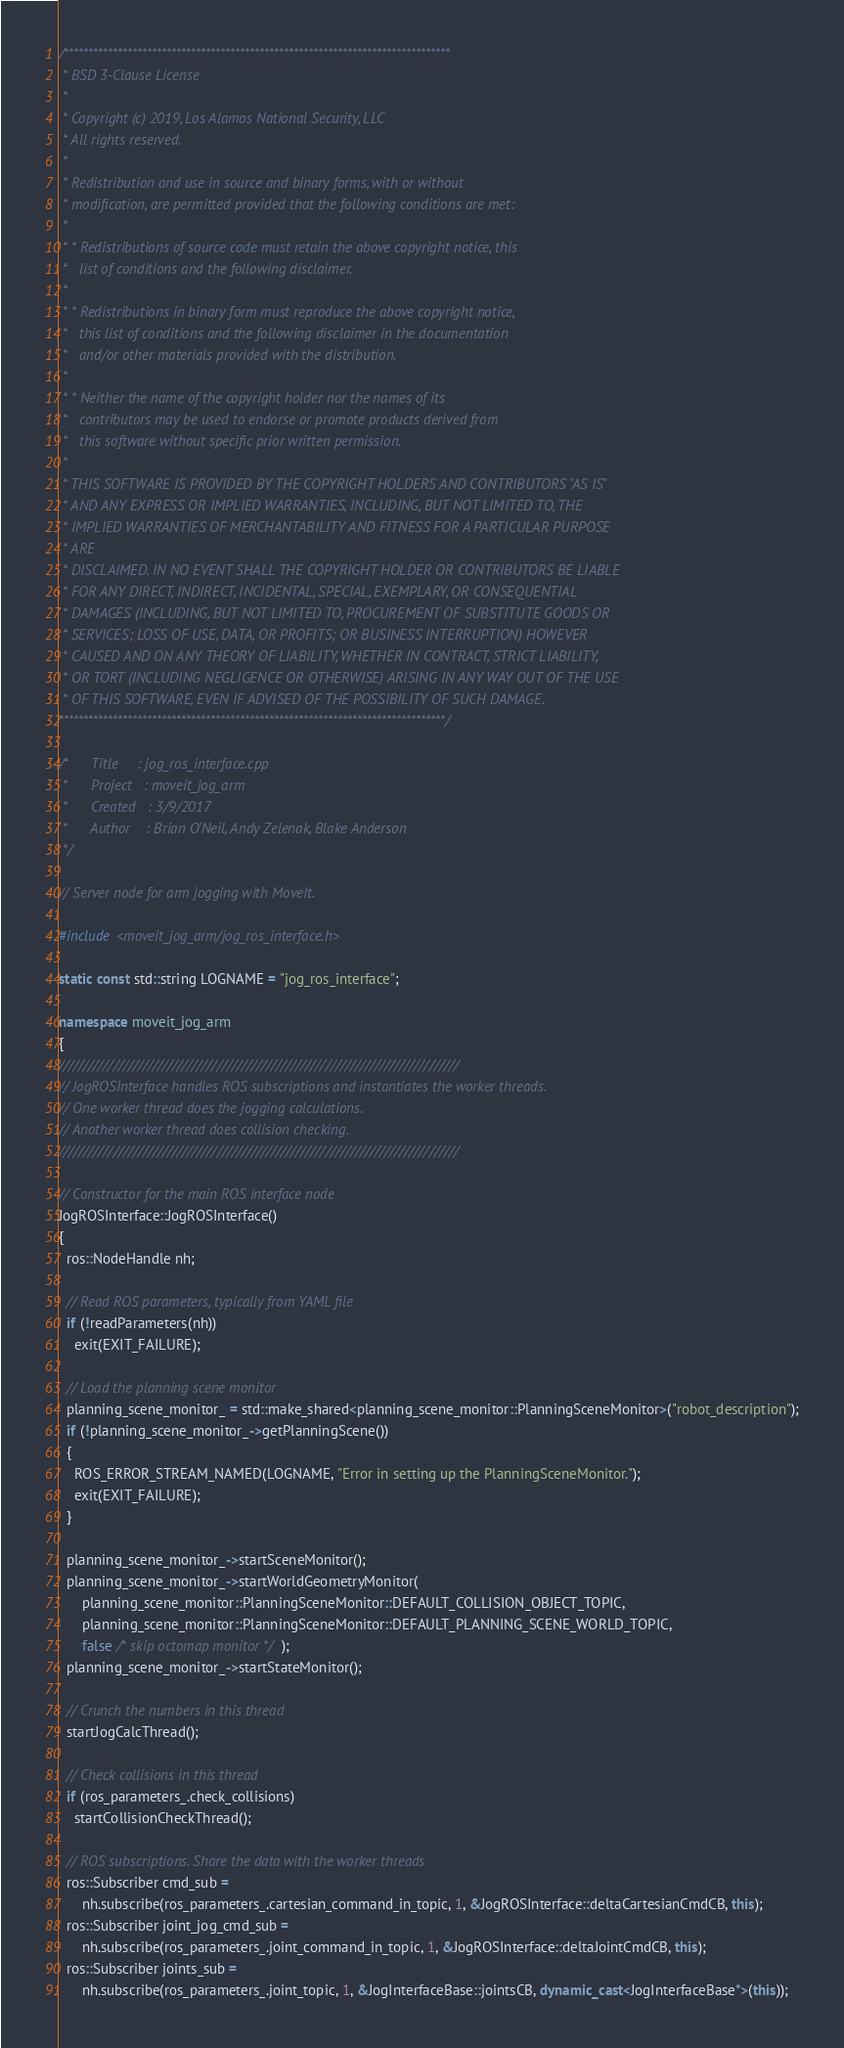<code> <loc_0><loc_0><loc_500><loc_500><_C++_>/*******************************************************************************
 * BSD 3-Clause License
 *
 * Copyright (c) 2019, Los Alamos National Security, LLC
 * All rights reserved.
 *
 * Redistribution and use in source and binary forms, with or without
 * modification, are permitted provided that the following conditions are met:
 *
 * * Redistributions of source code must retain the above copyright notice, this
 *   list of conditions and the following disclaimer.
 *
 * * Redistributions in binary form must reproduce the above copyright notice,
 *   this list of conditions and the following disclaimer in the documentation
 *   and/or other materials provided with the distribution.
 *
 * * Neither the name of the copyright holder nor the names of its
 *   contributors may be used to endorse or promote products derived from
 *   this software without specific prior written permission.
 *
 * THIS SOFTWARE IS PROVIDED BY THE COPYRIGHT HOLDERS AND CONTRIBUTORS "AS IS"
 * AND ANY EXPRESS OR IMPLIED WARRANTIES, INCLUDING, BUT NOT LIMITED TO, THE
 * IMPLIED WARRANTIES OF MERCHANTABILITY AND FITNESS FOR A PARTICULAR PURPOSE
 * ARE
 * DISCLAIMED. IN NO EVENT SHALL THE COPYRIGHT HOLDER OR CONTRIBUTORS BE LIABLE
 * FOR ANY DIRECT, INDIRECT, INCIDENTAL, SPECIAL, EXEMPLARY, OR CONSEQUENTIAL
 * DAMAGES (INCLUDING, BUT NOT LIMITED TO, PROCUREMENT OF SUBSTITUTE GOODS OR
 * SERVICES; LOSS OF USE, DATA, OR PROFITS; OR BUSINESS INTERRUPTION) HOWEVER
 * CAUSED AND ON ANY THEORY OF LIABILITY, WHETHER IN CONTRACT, STRICT LIABILITY,
 * OR TORT (INCLUDING NEGLIGENCE OR OTHERWISE) ARISING IN ANY WAY OUT OF THE USE
 * OF THIS SOFTWARE, EVEN IF ADVISED OF THE POSSIBILITY OF SUCH DAMAGE.
*******************************************************************************/

/*      Title     : jog_ros_interface.cpp
 *      Project   : moveit_jog_arm
 *      Created   : 3/9/2017
 *      Author    : Brian O'Neil, Andy Zelenak, Blake Anderson
 */

// Server node for arm jogging with MoveIt.

#include <moveit_jog_arm/jog_ros_interface.h>

static const std::string LOGNAME = "jog_ros_interface";

namespace moveit_jog_arm
{
/////////////////////////////////////////////////////////////////////////////////
// JogROSInterface handles ROS subscriptions and instantiates the worker threads.
// One worker thread does the jogging calculations.
// Another worker thread does collision checking.
/////////////////////////////////////////////////////////////////////////////////

// Constructor for the main ROS interface node
JogROSInterface::JogROSInterface()
{
  ros::NodeHandle nh;

  // Read ROS parameters, typically from YAML file
  if (!readParameters(nh))
    exit(EXIT_FAILURE);

  // Load the planning scene monitor
  planning_scene_monitor_ = std::make_shared<planning_scene_monitor::PlanningSceneMonitor>("robot_description");
  if (!planning_scene_monitor_->getPlanningScene())
  {
    ROS_ERROR_STREAM_NAMED(LOGNAME, "Error in setting up the PlanningSceneMonitor.");
    exit(EXIT_FAILURE);
  }

  planning_scene_monitor_->startSceneMonitor();
  planning_scene_monitor_->startWorldGeometryMonitor(
      planning_scene_monitor::PlanningSceneMonitor::DEFAULT_COLLISION_OBJECT_TOPIC,
      planning_scene_monitor::PlanningSceneMonitor::DEFAULT_PLANNING_SCENE_WORLD_TOPIC,
      false /* skip octomap monitor */);
  planning_scene_monitor_->startStateMonitor();

  // Crunch the numbers in this thread
  startJogCalcThread();

  // Check collisions in this thread
  if (ros_parameters_.check_collisions)
    startCollisionCheckThread();

  // ROS subscriptions. Share the data with the worker threads
  ros::Subscriber cmd_sub =
      nh.subscribe(ros_parameters_.cartesian_command_in_topic, 1, &JogROSInterface::deltaCartesianCmdCB, this);
  ros::Subscriber joint_jog_cmd_sub =
      nh.subscribe(ros_parameters_.joint_command_in_topic, 1, &JogROSInterface::deltaJointCmdCB, this);
  ros::Subscriber joints_sub =
      nh.subscribe(ros_parameters_.joint_topic, 1, &JogInterfaceBase::jointsCB, dynamic_cast<JogInterfaceBase*>(this));
</code> 